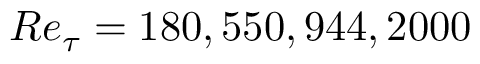<formula> <loc_0><loc_0><loc_500><loc_500>R e _ { \tau } = 1 8 0 , 5 5 0 , 9 4 4 , 2 0 0 0</formula> 